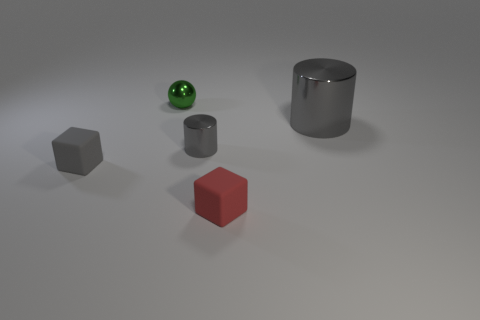There is a tiny gray cylinder behind the gray object left of the green shiny thing; what is it made of?
Your response must be concise. Metal. Is the number of gray metal cylinders right of the big metal cylinder the same as the number of gray cylinders that are in front of the tiny red rubber object?
Your response must be concise. Yes. Do the gray matte thing and the small red rubber object have the same shape?
Offer a very short reply. Yes. The object that is in front of the small gray metallic object and on the right side of the tiny gray rubber block is made of what material?
Your response must be concise. Rubber. How many other objects are the same shape as the small gray metal thing?
Your answer should be compact. 1. What is the size of the gray cylinder that is right of the tiny gray cylinder behind the tiny matte block to the right of the metal sphere?
Give a very brief answer. Large. Are there more tiny cubes that are on the left side of the small red matte object than large red matte spheres?
Offer a very short reply. Yes. Is there a gray ball?
Ensure brevity in your answer.  No. What number of rubber objects are the same size as the shiny ball?
Your answer should be very brief. 2. Is the number of matte things that are left of the tiny metal cylinder greater than the number of gray cylinders on the left side of the small green metallic object?
Offer a very short reply. Yes. 